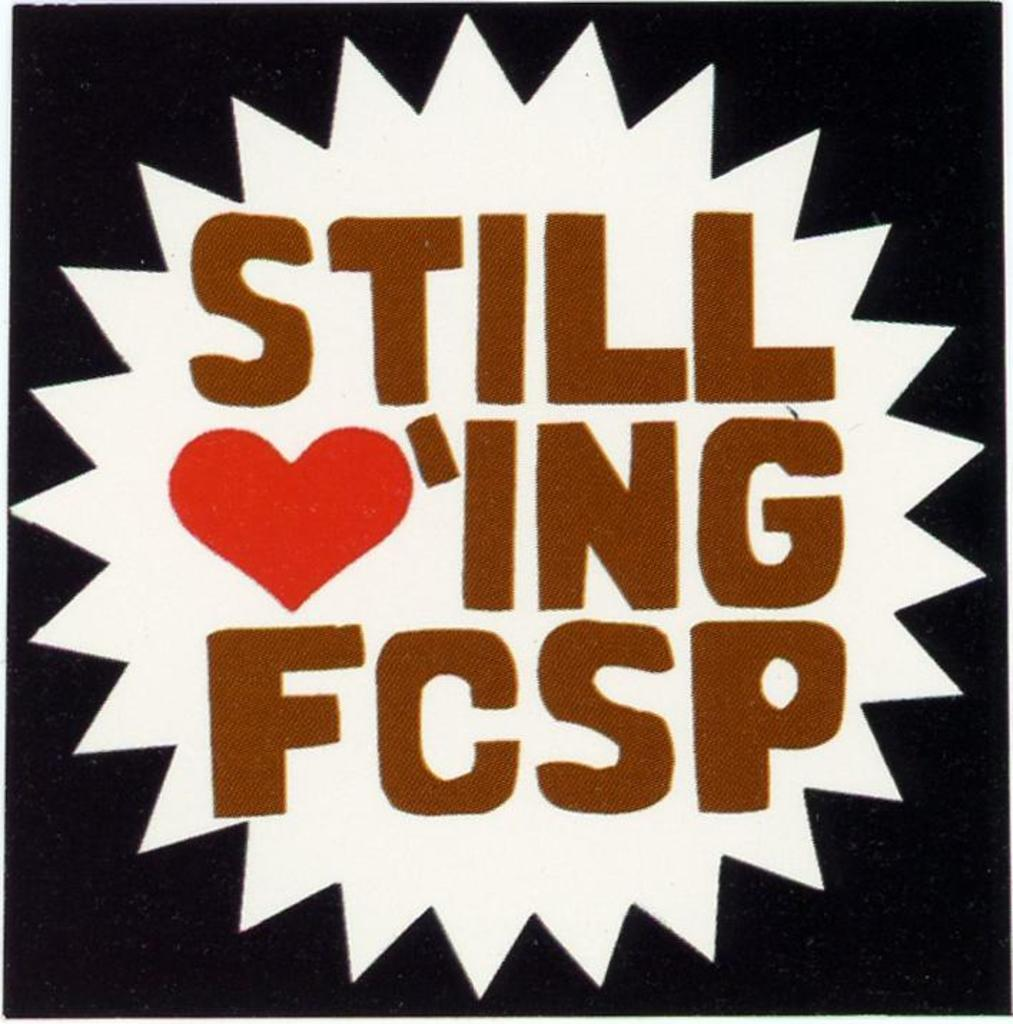<image>
Offer a succinct explanation of the picture presented. a graphic with a heart and it reads still loving FCSP 